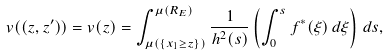Convert formula to latex. <formula><loc_0><loc_0><loc_500><loc_500>v ( ( z , z ^ { \prime } ) ) = v ( z ) = \int _ { \mu ( \{ x _ { 1 } \geq z \} ) } ^ { \mu ( R _ { E } ) } \frac { 1 } { h ^ { 2 } ( s ) } \left ( \int _ { 0 } ^ { s } f ^ { * } ( \xi ) \, d \xi \right ) \, d s ,</formula> 